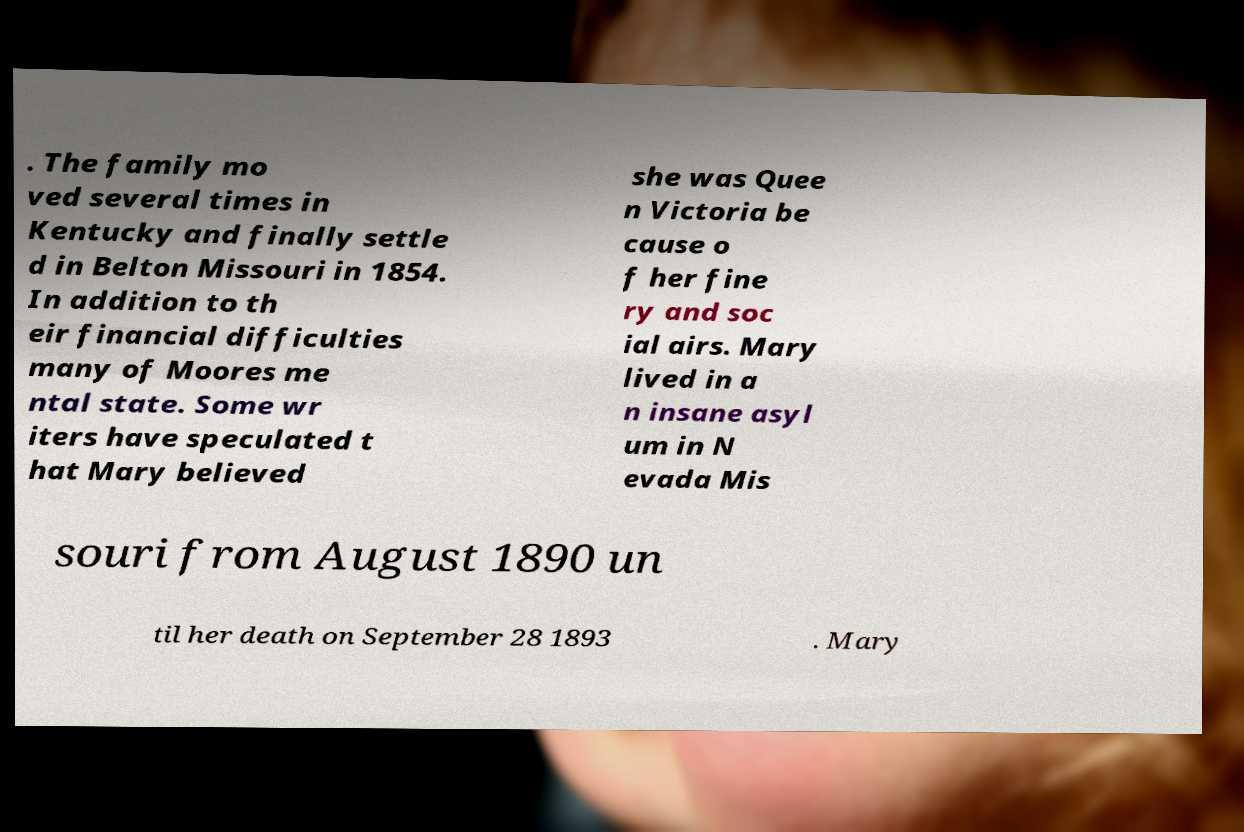Please read and relay the text visible in this image. What does it say? The text in the image appears fragmented and partially visible, mentioning several key details about a family's life journey and struggles. It notes that the family moved several times in Kentucky and settled in Belton, Missouri, in 1854. Moreover, it discusses someone named Mary, who was speculated by some writers to believe she was Queen Victoria due to her finery and airs, and lived in an insane asylum in Nevada, Missouri, from August 1890 until her death on September 28, 1893. 